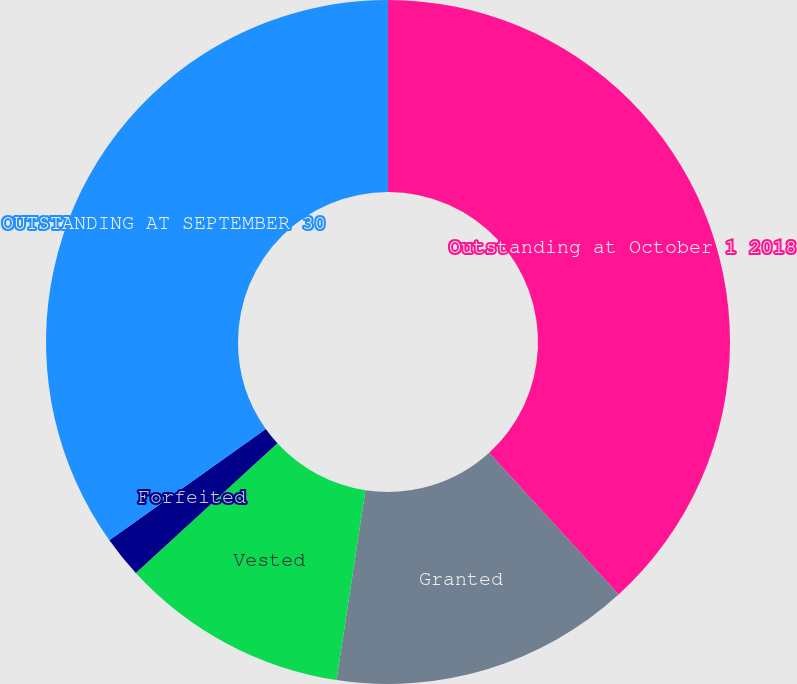Convert chart to OTSL. <chart><loc_0><loc_0><loc_500><loc_500><pie_chart><fcel>Outstanding at October 1 2018<fcel>Granted<fcel>Vested<fcel>Forfeited<fcel>OUTSTANDING AT SEPTEMBER 30<nl><fcel>38.22%<fcel>14.18%<fcel>10.79%<fcel>1.96%<fcel>34.84%<nl></chart> 